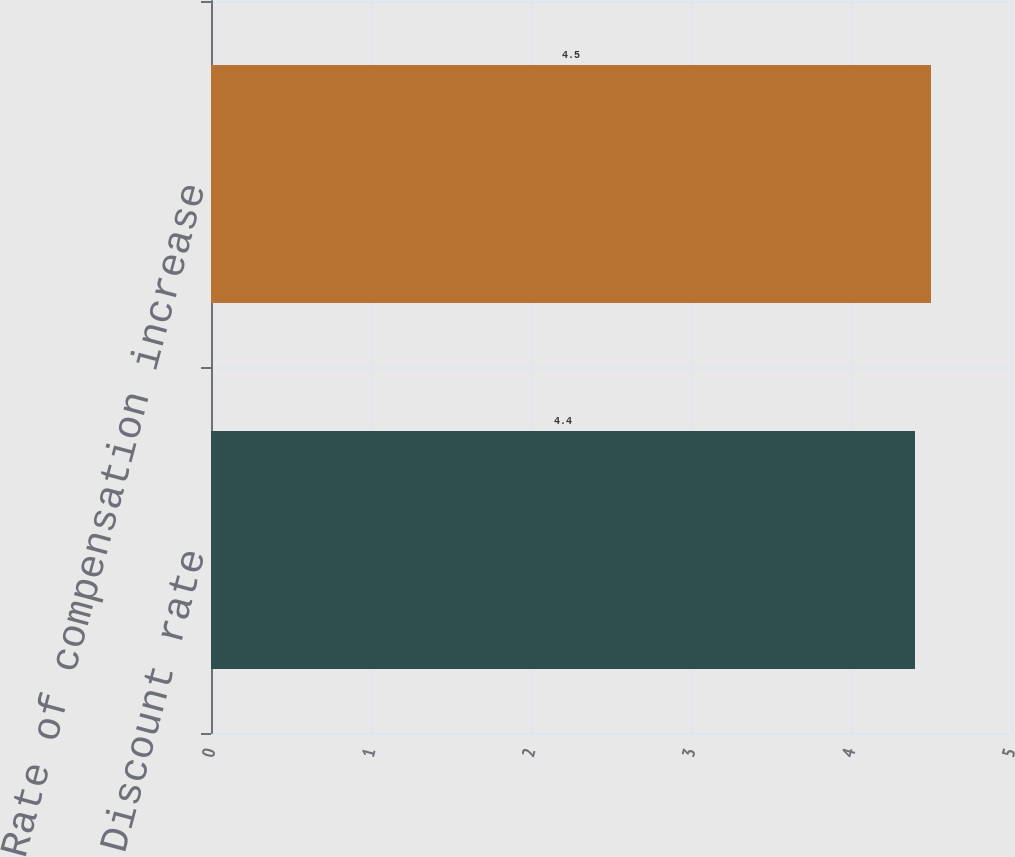<chart> <loc_0><loc_0><loc_500><loc_500><bar_chart><fcel>Discount rate<fcel>Rate of compensation increase<nl><fcel>4.4<fcel>4.5<nl></chart> 